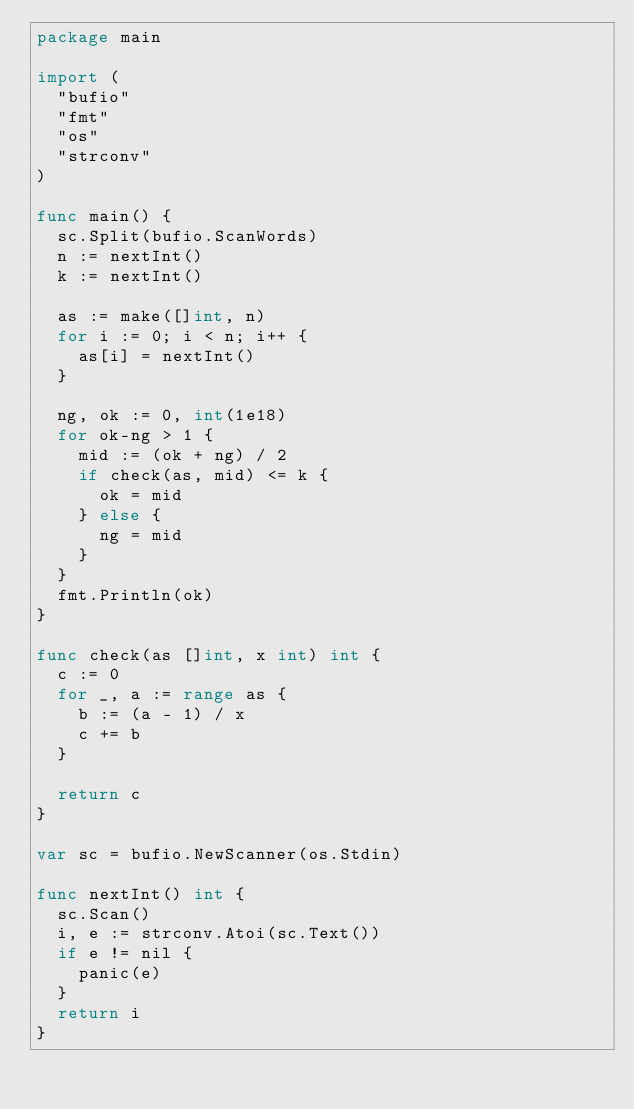<code> <loc_0><loc_0><loc_500><loc_500><_Go_>package main

import (
	"bufio"
	"fmt"
	"os"
	"strconv"
)

func main() {
	sc.Split(bufio.ScanWords)
	n := nextInt()
	k := nextInt()

	as := make([]int, n)
	for i := 0; i < n; i++ {
		as[i] = nextInt()
	}

	ng, ok := 0, int(1e18)
	for ok-ng > 1 {
		mid := (ok + ng) / 2
		if check(as, mid) <= k {
			ok = mid
		} else {
			ng = mid
		}
	}
	fmt.Println(ok)
}

func check(as []int, x int) int {
	c := 0
	for _, a := range as {
		b := (a - 1) / x
		c += b
	}

	return c
}

var sc = bufio.NewScanner(os.Stdin)

func nextInt() int {
	sc.Scan()
	i, e := strconv.Atoi(sc.Text())
	if e != nil {
		panic(e)
	}
	return i
}
</code> 